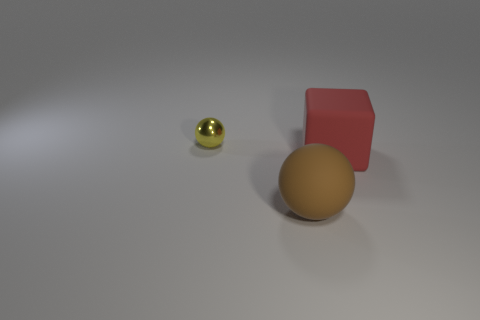Subtract all yellow balls. How many balls are left? 1 Subtract 1 cubes. How many cubes are left? 0 Add 2 brown rubber spheres. How many objects exist? 5 Subtract all blue cubes. How many brown balls are left? 1 Subtract all big brown matte balls. Subtract all large yellow rubber balls. How many objects are left? 2 Add 3 metal things. How many metal things are left? 4 Add 3 tiny yellow matte blocks. How many tiny yellow matte blocks exist? 3 Subtract 0 cyan spheres. How many objects are left? 3 Subtract all balls. How many objects are left? 1 Subtract all brown balls. Subtract all green cubes. How many balls are left? 1 